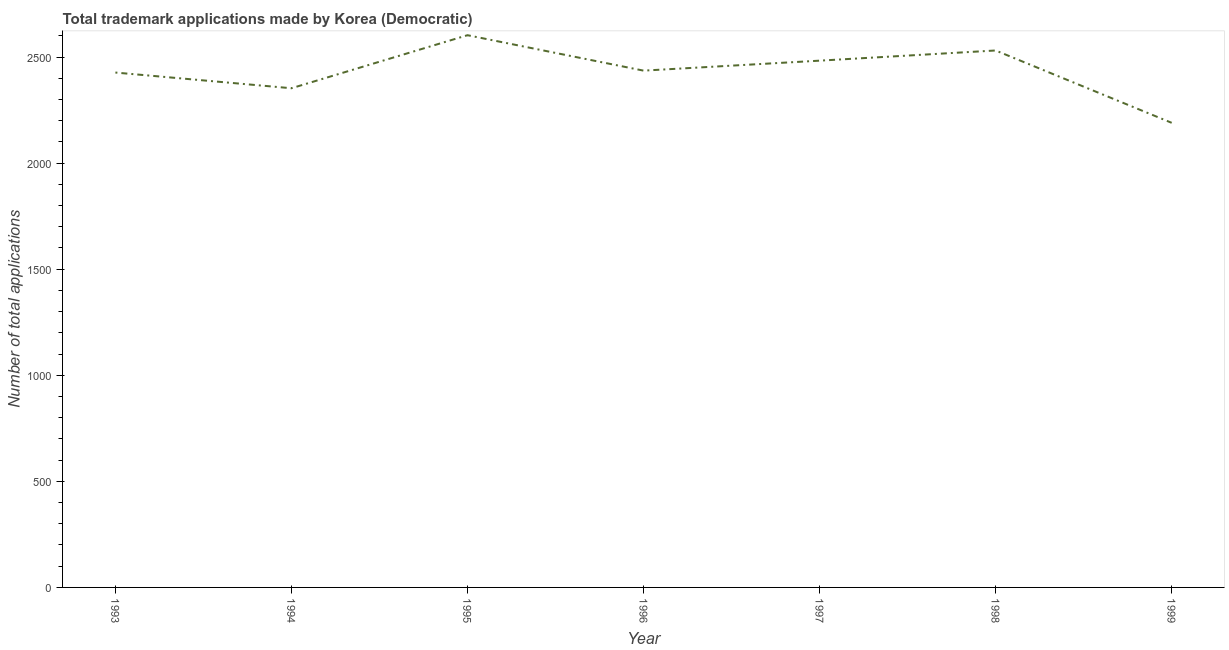What is the number of trademark applications in 1998?
Offer a very short reply. 2531. Across all years, what is the maximum number of trademark applications?
Your answer should be very brief. 2603. Across all years, what is the minimum number of trademark applications?
Offer a terse response. 2190. In which year was the number of trademark applications maximum?
Your response must be concise. 1995. What is the sum of the number of trademark applications?
Your answer should be compact. 1.70e+04. What is the difference between the number of trademark applications in 1995 and 1997?
Your answer should be compact. 120. What is the average number of trademark applications per year?
Offer a very short reply. 2431.86. What is the median number of trademark applications?
Ensure brevity in your answer.  2436. In how many years, is the number of trademark applications greater than 500 ?
Provide a succinct answer. 7. Do a majority of the years between 1995 and 1994 (inclusive) have number of trademark applications greater than 1300 ?
Your response must be concise. No. What is the ratio of the number of trademark applications in 1995 to that in 1996?
Your answer should be very brief. 1.07. Is the difference between the number of trademark applications in 1994 and 1995 greater than the difference between any two years?
Your answer should be very brief. No. Is the sum of the number of trademark applications in 1994 and 1996 greater than the maximum number of trademark applications across all years?
Give a very brief answer. Yes. What is the difference between the highest and the lowest number of trademark applications?
Make the answer very short. 413. In how many years, is the number of trademark applications greater than the average number of trademark applications taken over all years?
Make the answer very short. 4. How many years are there in the graph?
Offer a very short reply. 7. What is the difference between two consecutive major ticks on the Y-axis?
Keep it short and to the point. 500. Are the values on the major ticks of Y-axis written in scientific E-notation?
Give a very brief answer. No. Does the graph contain grids?
Ensure brevity in your answer.  No. What is the title of the graph?
Keep it short and to the point. Total trademark applications made by Korea (Democratic). What is the label or title of the X-axis?
Ensure brevity in your answer.  Year. What is the label or title of the Y-axis?
Offer a very short reply. Number of total applications. What is the Number of total applications in 1993?
Your answer should be very brief. 2427. What is the Number of total applications of 1994?
Provide a succinct answer. 2353. What is the Number of total applications of 1995?
Your answer should be very brief. 2603. What is the Number of total applications of 1996?
Give a very brief answer. 2436. What is the Number of total applications in 1997?
Keep it short and to the point. 2483. What is the Number of total applications in 1998?
Your response must be concise. 2531. What is the Number of total applications of 1999?
Offer a very short reply. 2190. What is the difference between the Number of total applications in 1993 and 1994?
Provide a succinct answer. 74. What is the difference between the Number of total applications in 1993 and 1995?
Offer a very short reply. -176. What is the difference between the Number of total applications in 1993 and 1996?
Offer a terse response. -9. What is the difference between the Number of total applications in 1993 and 1997?
Your response must be concise. -56. What is the difference between the Number of total applications in 1993 and 1998?
Your response must be concise. -104. What is the difference between the Number of total applications in 1993 and 1999?
Your response must be concise. 237. What is the difference between the Number of total applications in 1994 and 1995?
Your answer should be compact. -250. What is the difference between the Number of total applications in 1994 and 1996?
Ensure brevity in your answer.  -83. What is the difference between the Number of total applications in 1994 and 1997?
Your answer should be compact. -130. What is the difference between the Number of total applications in 1994 and 1998?
Your answer should be compact. -178. What is the difference between the Number of total applications in 1994 and 1999?
Offer a very short reply. 163. What is the difference between the Number of total applications in 1995 and 1996?
Give a very brief answer. 167. What is the difference between the Number of total applications in 1995 and 1997?
Keep it short and to the point. 120. What is the difference between the Number of total applications in 1995 and 1999?
Provide a succinct answer. 413. What is the difference between the Number of total applications in 1996 and 1997?
Ensure brevity in your answer.  -47. What is the difference between the Number of total applications in 1996 and 1998?
Keep it short and to the point. -95. What is the difference between the Number of total applications in 1996 and 1999?
Make the answer very short. 246. What is the difference between the Number of total applications in 1997 and 1998?
Ensure brevity in your answer.  -48. What is the difference between the Number of total applications in 1997 and 1999?
Provide a succinct answer. 293. What is the difference between the Number of total applications in 1998 and 1999?
Offer a very short reply. 341. What is the ratio of the Number of total applications in 1993 to that in 1994?
Your answer should be very brief. 1.03. What is the ratio of the Number of total applications in 1993 to that in 1995?
Provide a short and direct response. 0.93. What is the ratio of the Number of total applications in 1993 to that in 1996?
Your answer should be very brief. 1. What is the ratio of the Number of total applications in 1993 to that in 1998?
Your answer should be compact. 0.96. What is the ratio of the Number of total applications in 1993 to that in 1999?
Offer a terse response. 1.11. What is the ratio of the Number of total applications in 1994 to that in 1995?
Offer a very short reply. 0.9. What is the ratio of the Number of total applications in 1994 to that in 1997?
Offer a very short reply. 0.95. What is the ratio of the Number of total applications in 1994 to that in 1998?
Keep it short and to the point. 0.93. What is the ratio of the Number of total applications in 1994 to that in 1999?
Offer a very short reply. 1.07. What is the ratio of the Number of total applications in 1995 to that in 1996?
Your response must be concise. 1.07. What is the ratio of the Number of total applications in 1995 to that in 1997?
Offer a very short reply. 1.05. What is the ratio of the Number of total applications in 1995 to that in 1998?
Your answer should be compact. 1.03. What is the ratio of the Number of total applications in 1995 to that in 1999?
Your answer should be compact. 1.19. What is the ratio of the Number of total applications in 1996 to that in 1999?
Your answer should be compact. 1.11. What is the ratio of the Number of total applications in 1997 to that in 1998?
Keep it short and to the point. 0.98. What is the ratio of the Number of total applications in 1997 to that in 1999?
Provide a short and direct response. 1.13. What is the ratio of the Number of total applications in 1998 to that in 1999?
Offer a terse response. 1.16. 